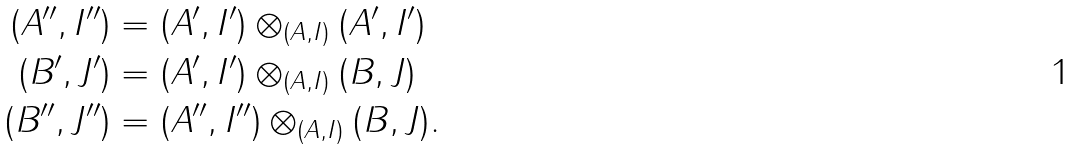<formula> <loc_0><loc_0><loc_500><loc_500>( A ^ { \prime \prime } , I ^ { \prime \prime } ) & = ( A ^ { \prime } , I ^ { \prime } ) \otimes _ { ( A , I ) } ( A ^ { \prime } , I ^ { \prime } ) \\ ( B ^ { \prime } , J ^ { \prime } ) & = ( A ^ { \prime } , I ^ { \prime } ) \otimes _ { ( A , I ) } ( B , J ) \\ ( B ^ { \prime \prime } , J ^ { \prime \prime } ) & = ( A ^ { \prime \prime } , I ^ { \prime \prime } ) \otimes _ { ( A , I ) } ( B , J ) .</formula> 